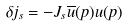<formula> <loc_0><loc_0><loc_500><loc_500>\delta j _ { s } = - J _ { s } \overline { u } ( p ) u ( p )</formula> 